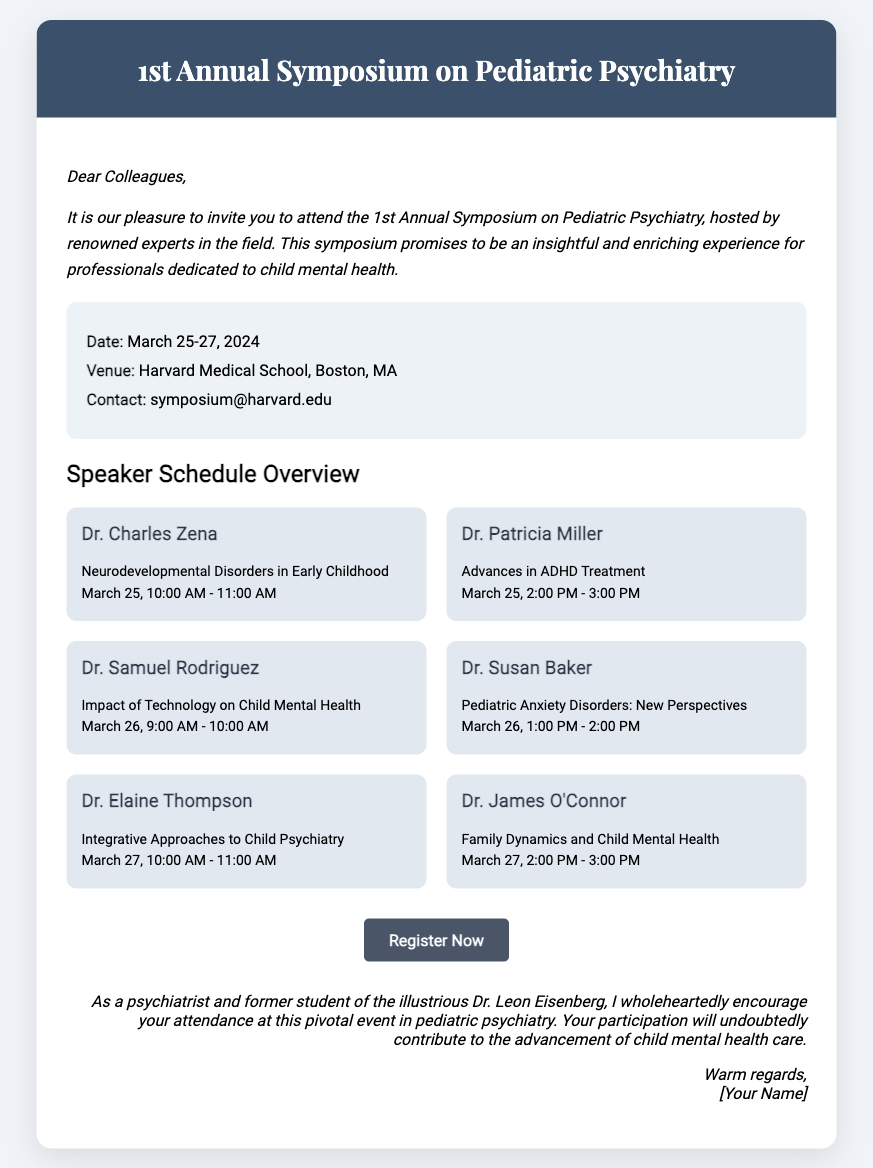What is the date of the symposium? The date of the symposium is clearly stated as March 25-27, 2024.
Answer: March 25-27, 2024 Who is speaking about Neurodevelopmental Disorders? The speaker addressing this topic is mentioned in the speaker list as Dr. Charles Zena.
Answer: Dr. Charles Zena What is the venue of the symposium? The venue is specified in the details section as Harvard Medical School, Boston, MA.
Answer: Harvard Medical School, Boston, MA What time does Dr. Patricia Miller's presentation start? The time for Dr. Patricia Miller's talk is provided in the schedule as 2:00 PM on March 25.
Answer: 2:00 PM How many speakers are featured in the speaker schedule overview? By counting the individual speakers listed, we can see there are a total of six speakers.
Answer: Six What is the central theme of the symposium? The invitation section indicates that the symposium is focused on pediatric psychiatry.
Answer: Pediatric Psychiatry What kind of approaches is Dr. Elaine Thompson discussing? The speaker information denotes that Dr. Elaine Thompson will talk about integrative approaches.
Answer: Integrative Approaches How can attendees register for the symposium? The call to action includes a button labeled "Register Now," directing attendees on how to proceed.
Answer: Register Now What should attendees do after reading this RSVP? The sign-off encourages attendance and emphasizes contribution to child mental health care.
Answer: Attend the symposium 